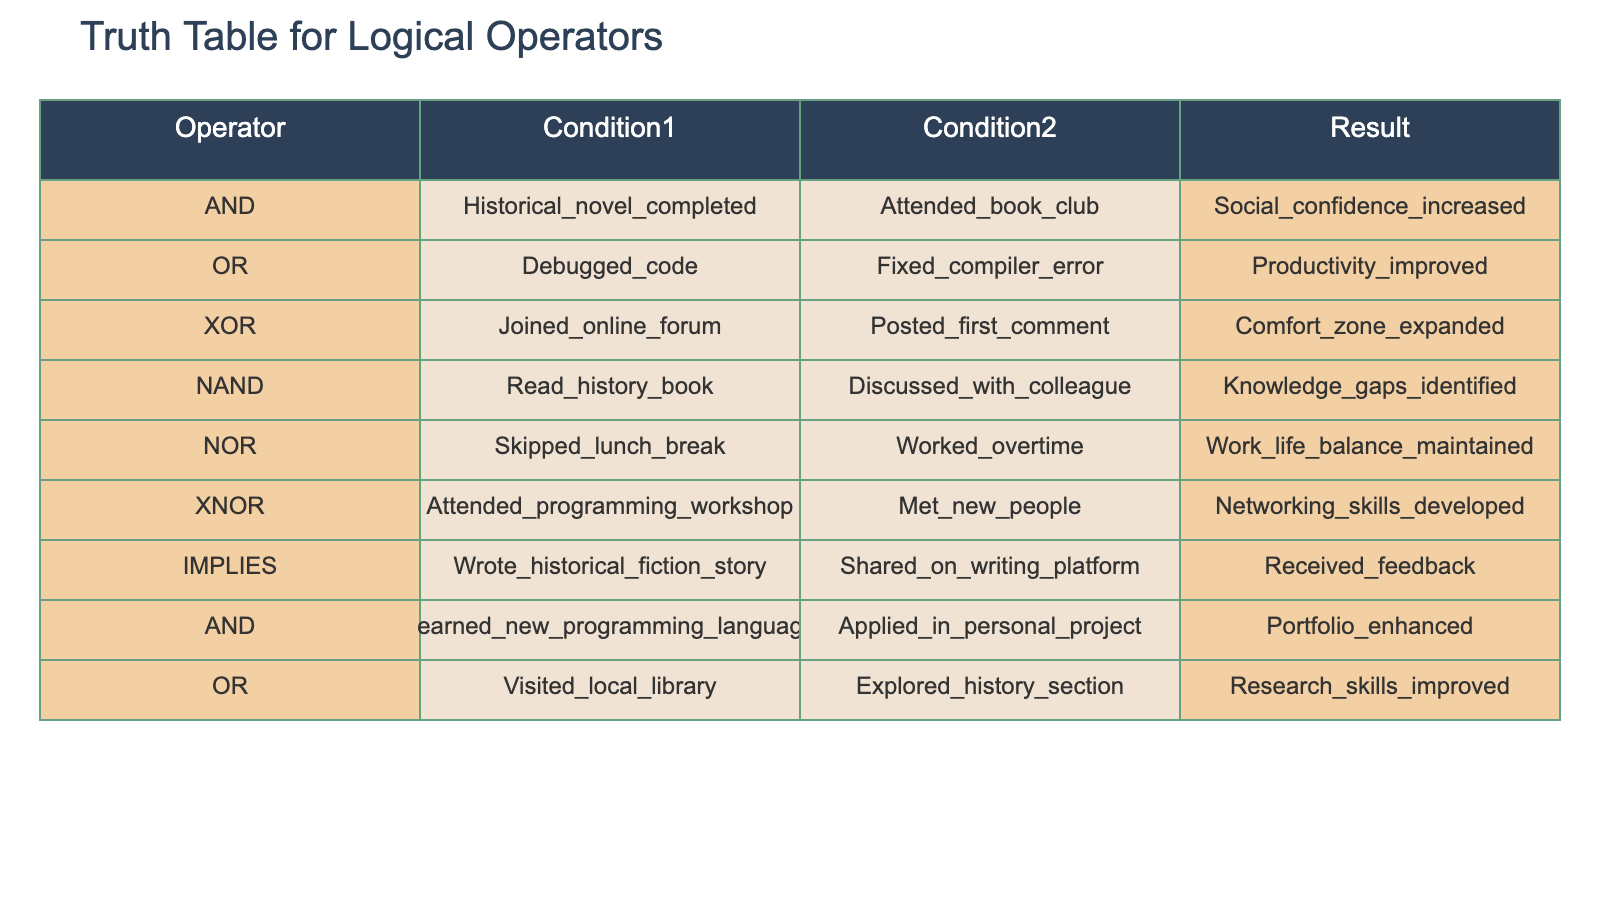What is the result when both conditions of the AND operator are true? The AND operator has two conditions: "Historical_novel_completed" and "Attended_book_club". According to the table, if both conditions are met, the result is "Social_confidence_increased".
Answer: Social confidence increased Which logical operator has the result of "Productivity_improved"? The operator "OR" has the result of "Productivity_improved". The specific conditions for this operator are "Debugged_code" and "Fixed_compiler_error".
Answer: OR Are there any operators that yield "Knowledge_gaps_identified"? Yes, the NAND operator yields "Knowledge_gaps_identified" if both conditions "Read_history_book" and "Discussed_with_colleague" are met.
Answer: Yes How many unique results are there in the table? By examining the results column, the unique results are "Social_confidence_increased", "Productivity_improved", "Comfort_zone_expanded", "Knowledge_gaps_identified", "Work_life_balance_maintained", "Networking_skills_developed", "Received_feedback", "Portfolio_enhanced", and "Research_skills_improved". Counting these gives a total of 9 unique results.
Answer: 9 What are the combined conditions for the operator that leads to "Networking_skills_developed"? The XNOR operator leads to "Networking_skills_developed" when both conditions "Attended_programming_workshop" and "Met_new_people" are true. Therefore, to achieve this result, both conditions must be combined and satisfied together.
Answer: Attended programming workshop and met new people If one condition of the IMPLIES operator is not met, what is the expected outcome? The IMPLIES operator states that if "Wrote_historical_fiction_story" is not met, then "Received_feedback" cannot occur. Thus, without writing the story, the outcome can be seen as null or non-existent.
Answer: Feedback not received What happens to work-life balance when lunch is skipped? According to the NOR operator, if "Skipped_lunch_break" is met, the result is "Work_life_balance_maintained". This indicates that skipping lunch does not negatively impact work-life balance if the second condition is false (meaning no overtime).
Answer: Work-life balance maintained Which condition pairs lead to improved research skills? The OR operator leads to "Research_skills_improved" with the conditions "Visited_local_library" and "Explored_history_section". Either one of the conditions being true is sufficient for improving research skills.
Answer: Local library visit or section exploration 